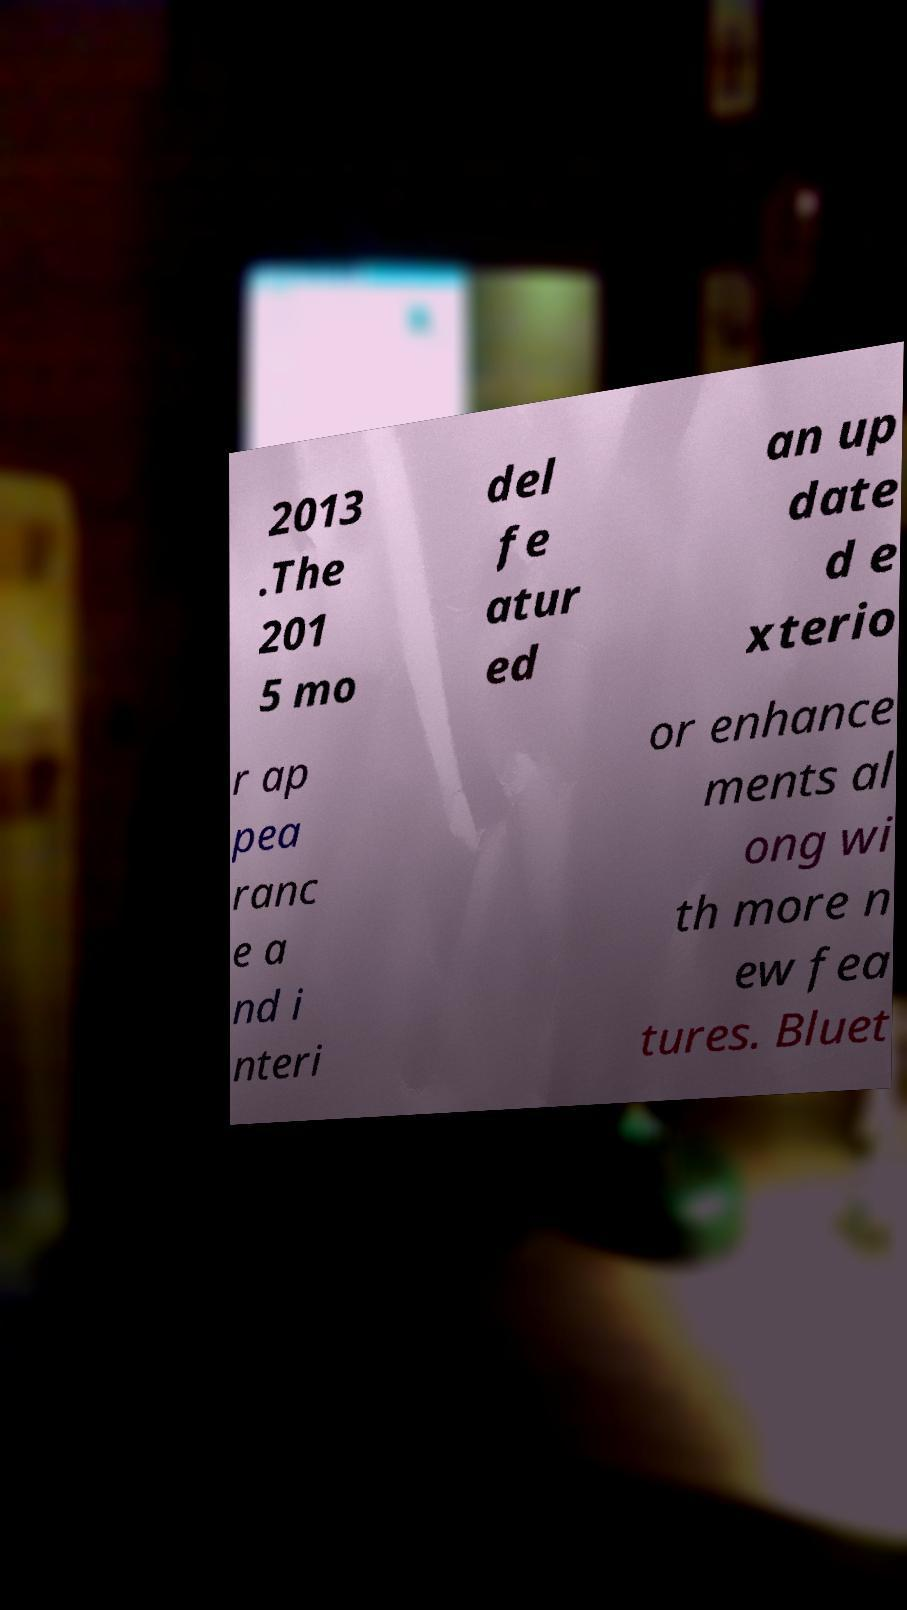I need the written content from this picture converted into text. Can you do that? 2013 .The 201 5 mo del fe atur ed an up date d e xterio r ap pea ranc e a nd i nteri or enhance ments al ong wi th more n ew fea tures. Bluet 